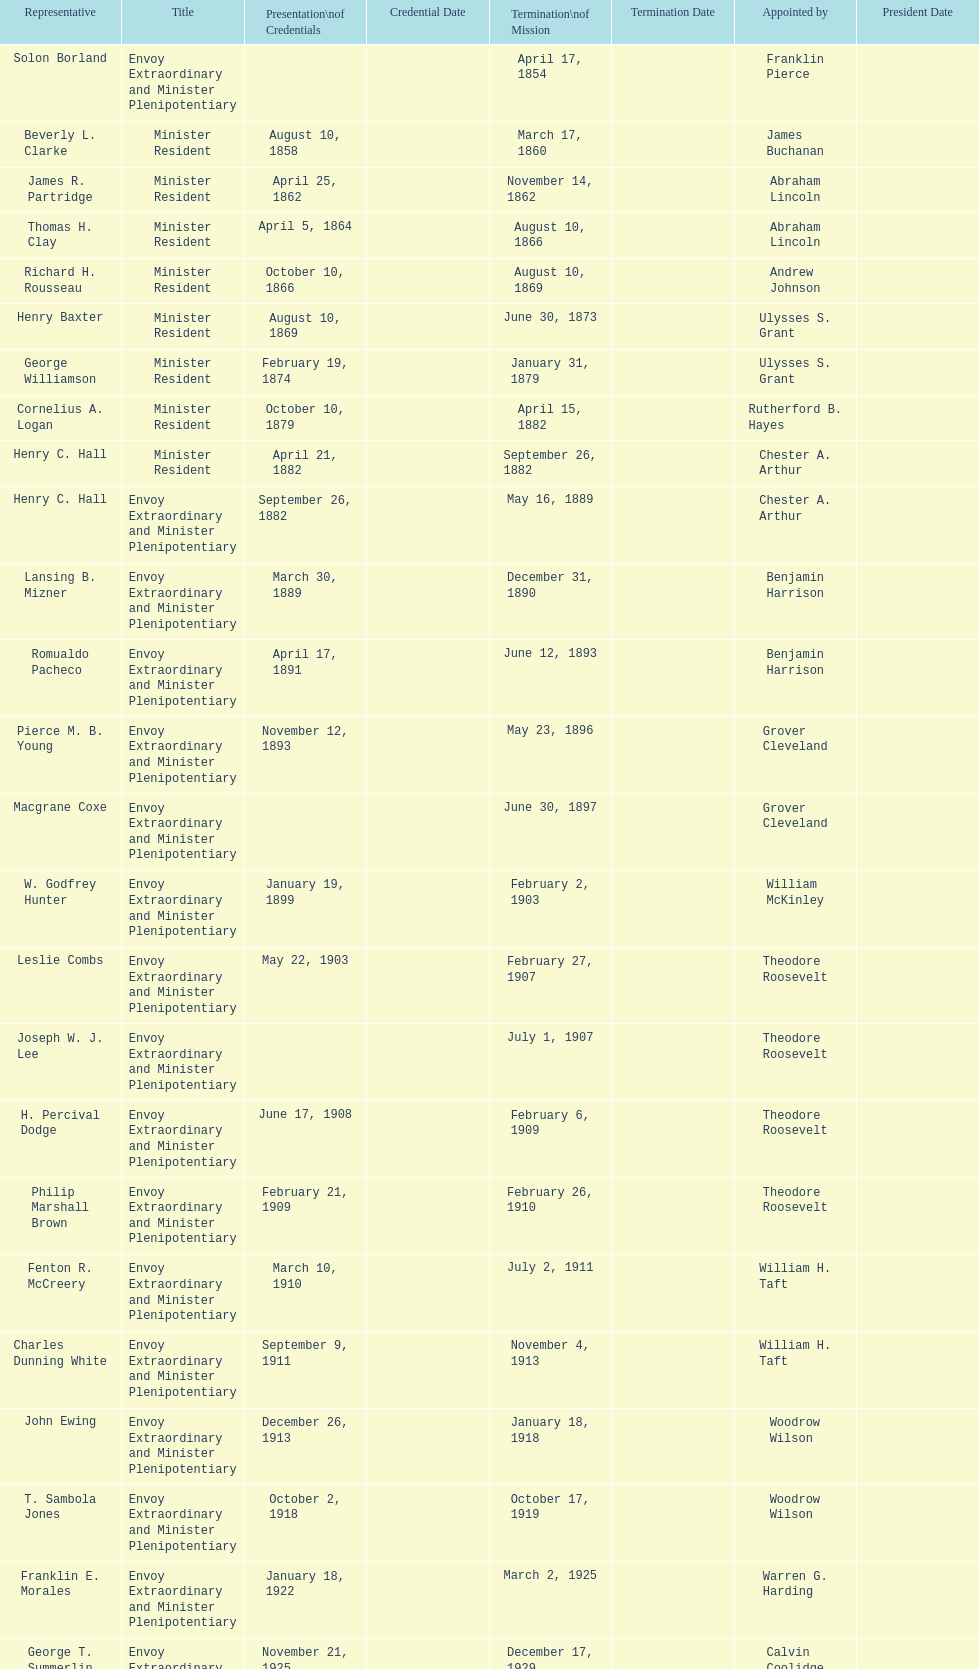How many representatives were assigned by theodore roosevelt? 4. 